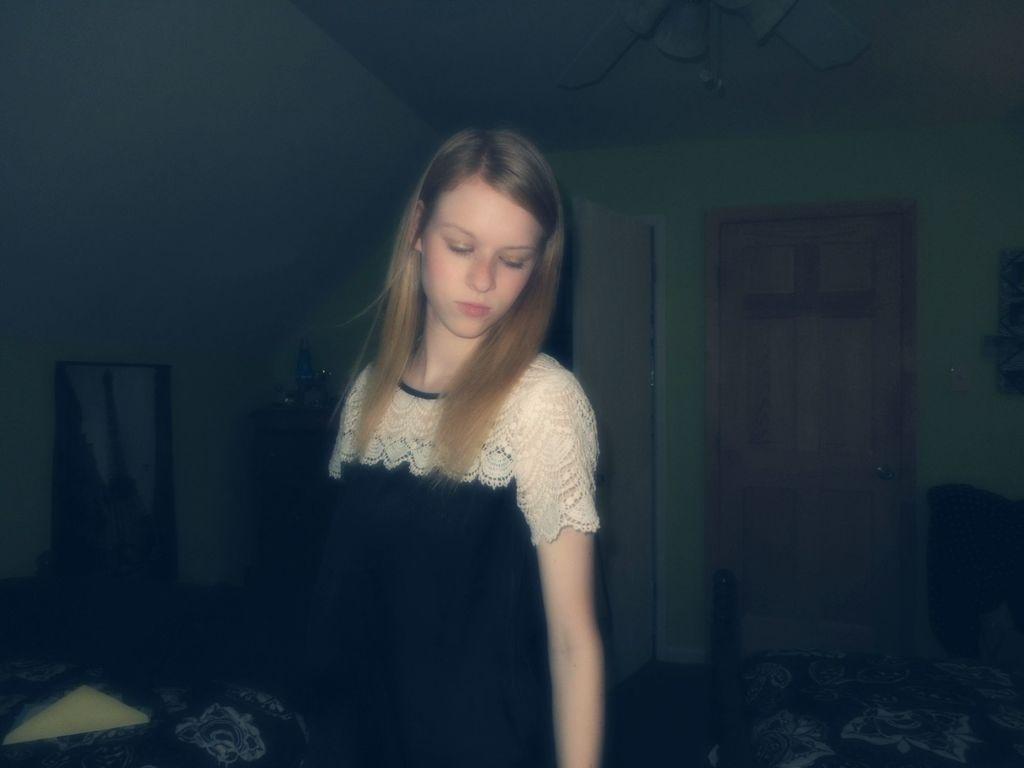Can you describe this image briefly? In the image we can see a girl wearing clothes. Here we can see the door, wall and the floor. The background is pale dark. 